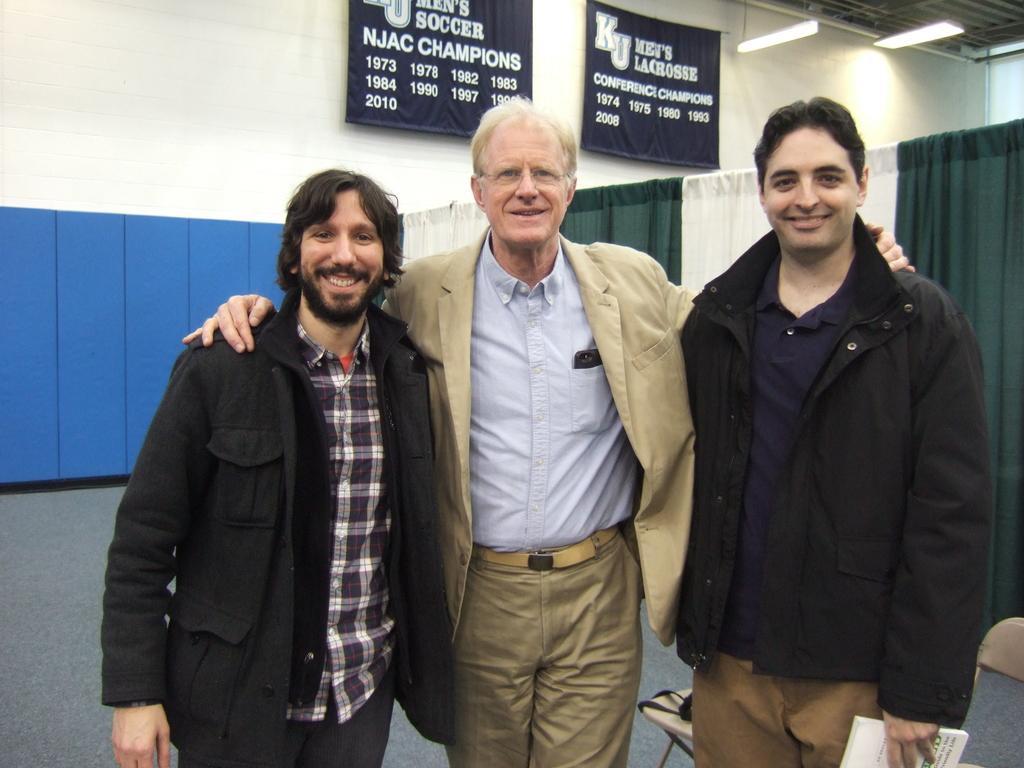Please provide a concise description of this image. In this image I can see three men are standing, I can see smile on their faces. I can also see two of them are wearing black colour jackets. In the background I can see few lines, few black colour things and on it I can see something is written. 